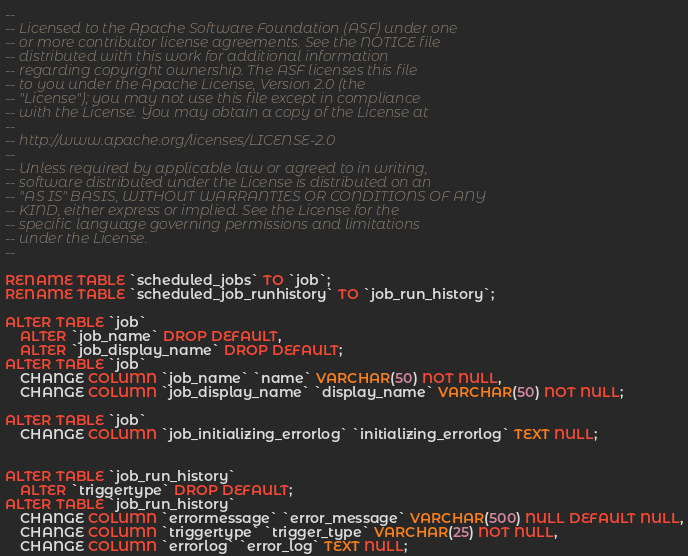Convert code to text. <code><loc_0><loc_0><loc_500><loc_500><_SQL_>--
-- Licensed to the Apache Software Foundation (ASF) under one
-- or more contributor license agreements. See the NOTICE file
-- distributed with this work for additional information
-- regarding copyright ownership. The ASF licenses this file
-- to you under the Apache License, Version 2.0 (the
-- "License"); you may not use this file except in compliance
-- with the License. You may obtain a copy of the License at
--
-- http://www.apache.org/licenses/LICENSE-2.0
--
-- Unless required by applicable law or agreed to in writing,
-- software distributed under the License is distributed on an
-- "AS IS" BASIS, WITHOUT WARRANTIES OR CONDITIONS OF ANY
-- KIND, either express or implied. See the License for the
-- specific language governing permissions and limitations
-- under the License.
--

RENAME TABLE `scheduled_jobs` TO `job`;
RENAME TABLE `scheduled_job_runhistory` TO `job_run_history`;

ALTER TABLE `job`
	ALTER `job_name` DROP DEFAULT,
	ALTER `job_display_name` DROP DEFAULT;
ALTER TABLE `job`
	CHANGE COLUMN `job_name` `name` VARCHAR(50) NOT NULL,
	CHANGE COLUMN `job_display_name` `display_name` VARCHAR(50) NOT NULL;

ALTER TABLE `job`
	CHANGE COLUMN `job_initializing_errorlog` `initializing_errorlog` TEXT NULL;


ALTER TABLE `job_run_history`
	ALTER `triggertype` DROP DEFAULT;
ALTER TABLE `job_run_history`
	CHANGE COLUMN `errormessage` `error_message` VARCHAR(500) NULL DEFAULT NULL,
	CHANGE COLUMN `triggertype` `trigger_type` VARCHAR(25) NOT NULL,
	CHANGE COLUMN `errorlog` `error_log` TEXT NULL;
</code> 